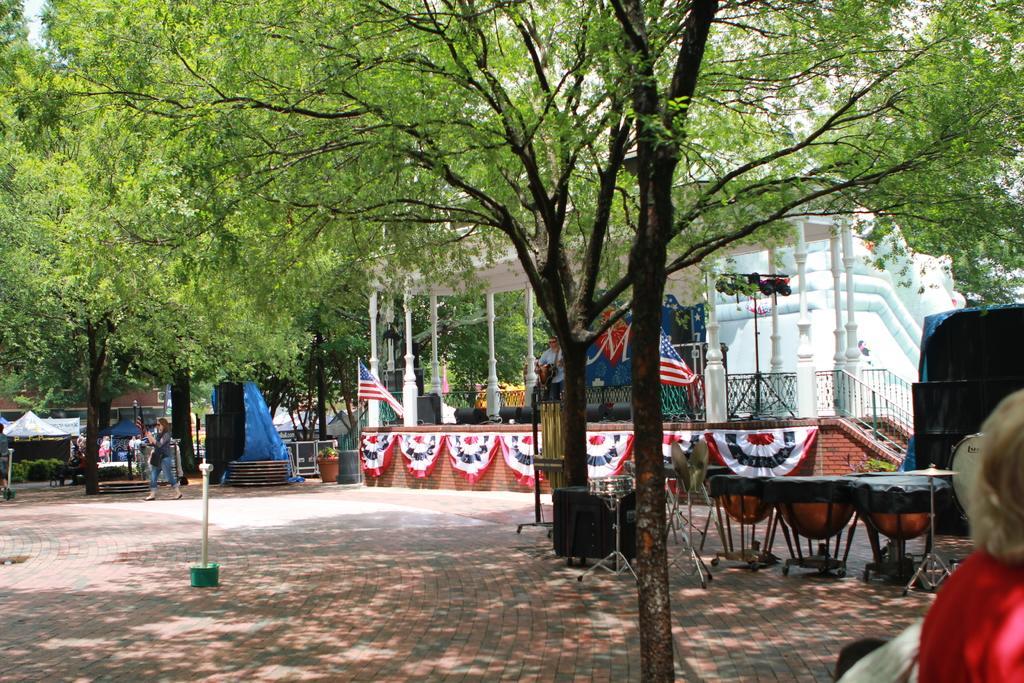Could you give a brief overview of what you see in this image? Here in this picture we can see plants and trees present over a place and in the front we can see a shed present and we can also see a flag post in the middle and we can see tents present in the far and we can see people walking on the ground and in the front we can see drums and cymbal plates present over a place and we can also see speakers present and we can also see lights present. 